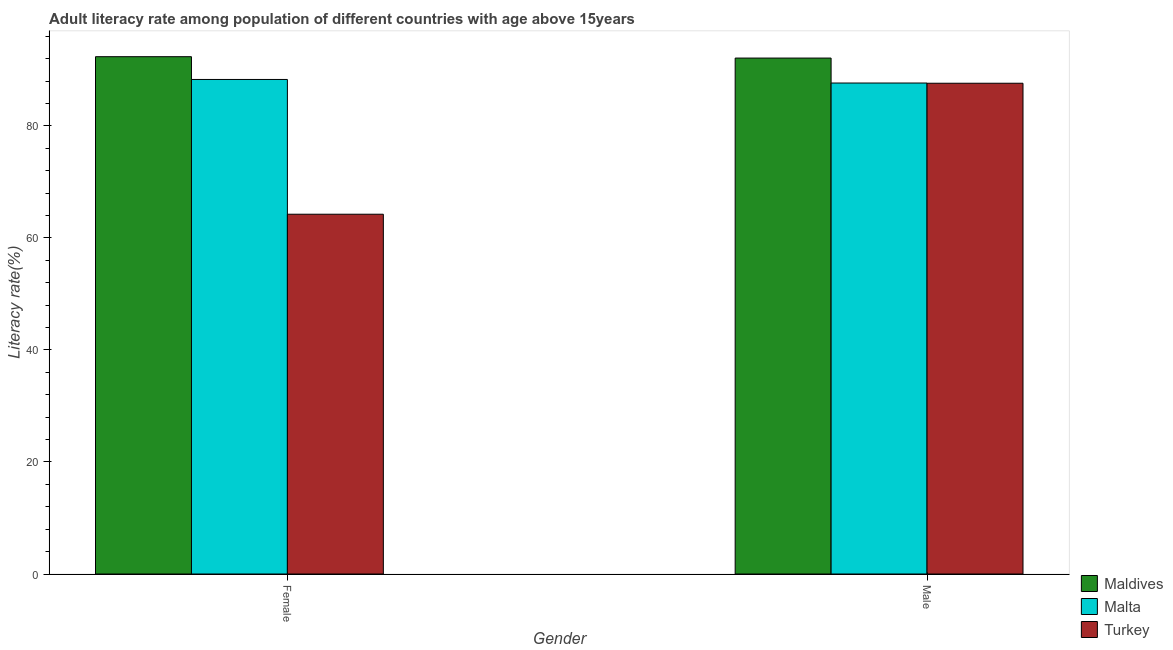How many different coloured bars are there?
Make the answer very short. 3. Are the number of bars per tick equal to the number of legend labels?
Your answer should be compact. Yes. What is the label of the 2nd group of bars from the left?
Your answer should be compact. Male. What is the female adult literacy rate in Maldives?
Keep it short and to the point. 92.36. Across all countries, what is the maximum female adult literacy rate?
Ensure brevity in your answer.  92.36. Across all countries, what is the minimum male adult literacy rate?
Your response must be concise. 87.62. In which country was the female adult literacy rate maximum?
Provide a short and direct response. Maldives. In which country was the male adult literacy rate minimum?
Offer a terse response. Turkey. What is the total male adult literacy rate in the graph?
Provide a short and direct response. 267.39. What is the difference between the male adult literacy rate in Turkey and that in Malta?
Make the answer very short. -0.04. What is the difference between the male adult literacy rate in Malta and the female adult literacy rate in Turkey?
Ensure brevity in your answer.  23.43. What is the average male adult literacy rate per country?
Ensure brevity in your answer.  89.13. What is the difference between the male adult literacy rate and female adult literacy rate in Turkey?
Provide a short and direct response. 23.39. In how many countries, is the male adult literacy rate greater than 72 %?
Your answer should be compact. 3. What is the ratio of the male adult literacy rate in Turkey to that in Maldives?
Your response must be concise. 0.95. In how many countries, is the male adult literacy rate greater than the average male adult literacy rate taken over all countries?
Ensure brevity in your answer.  1. What does the 1st bar from the right in Male represents?
Keep it short and to the point. Turkey. How many countries are there in the graph?
Your answer should be compact. 3. Are the values on the major ticks of Y-axis written in scientific E-notation?
Your response must be concise. No. Does the graph contain grids?
Your response must be concise. No. Where does the legend appear in the graph?
Give a very brief answer. Bottom right. What is the title of the graph?
Make the answer very short. Adult literacy rate among population of different countries with age above 15years. What is the label or title of the X-axis?
Give a very brief answer. Gender. What is the label or title of the Y-axis?
Your answer should be very brief. Literacy rate(%). What is the Literacy rate(%) in Maldives in Female?
Offer a very short reply. 92.36. What is the Literacy rate(%) of Malta in Female?
Your answer should be compact. 88.29. What is the Literacy rate(%) in Turkey in Female?
Offer a very short reply. 64.23. What is the Literacy rate(%) in Maldives in Male?
Your answer should be compact. 92.11. What is the Literacy rate(%) of Malta in Male?
Your answer should be very brief. 87.66. What is the Literacy rate(%) of Turkey in Male?
Keep it short and to the point. 87.62. Across all Gender, what is the maximum Literacy rate(%) in Maldives?
Your answer should be very brief. 92.36. Across all Gender, what is the maximum Literacy rate(%) in Malta?
Your response must be concise. 88.29. Across all Gender, what is the maximum Literacy rate(%) in Turkey?
Your answer should be compact. 87.62. Across all Gender, what is the minimum Literacy rate(%) in Maldives?
Make the answer very short. 92.11. Across all Gender, what is the minimum Literacy rate(%) of Malta?
Offer a terse response. 87.66. Across all Gender, what is the minimum Literacy rate(%) in Turkey?
Make the answer very short. 64.23. What is the total Literacy rate(%) of Maldives in the graph?
Provide a succinct answer. 184.47. What is the total Literacy rate(%) in Malta in the graph?
Give a very brief answer. 175.95. What is the total Literacy rate(%) in Turkey in the graph?
Give a very brief answer. 151.85. What is the difference between the Literacy rate(%) of Maldives in Female and that in Male?
Offer a terse response. 0.24. What is the difference between the Literacy rate(%) in Malta in Female and that in Male?
Provide a succinct answer. 0.64. What is the difference between the Literacy rate(%) of Turkey in Female and that in Male?
Ensure brevity in your answer.  -23.39. What is the difference between the Literacy rate(%) in Maldives in Female and the Literacy rate(%) in Malta in Male?
Make the answer very short. 4.7. What is the difference between the Literacy rate(%) in Maldives in Female and the Literacy rate(%) in Turkey in Male?
Your answer should be compact. 4.74. What is the difference between the Literacy rate(%) in Malta in Female and the Literacy rate(%) in Turkey in Male?
Offer a very short reply. 0.67. What is the average Literacy rate(%) in Maldives per Gender?
Make the answer very short. 92.24. What is the average Literacy rate(%) in Malta per Gender?
Give a very brief answer. 87.97. What is the average Literacy rate(%) in Turkey per Gender?
Ensure brevity in your answer.  75.93. What is the difference between the Literacy rate(%) in Maldives and Literacy rate(%) in Malta in Female?
Keep it short and to the point. 4.07. What is the difference between the Literacy rate(%) in Maldives and Literacy rate(%) in Turkey in Female?
Provide a succinct answer. 28.13. What is the difference between the Literacy rate(%) in Malta and Literacy rate(%) in Turkey in Female?
Keep it short and to the point. 24.06. What is the difference between the Literacy rate(%) in Maldives and Literacy rate(%) in Malta in Male?
Provide a succinct answer. 4.46. What is the difference between the Literacy rate(%) of Maldives and Literacy rate(%) of Turkey in Male?
Provide a succinct answer. 4.49. What is the difference between the Literacy rate(%) in Malta and Literacy rate(%) in Turkey in Male?
Make the answer very short. 0.04. What is the ratio of the Literacy rate(%) of Maldives in Female to that in Male?
Provide a short and direct response. 1. What is the ratio of the Literacy rate(%) of Malta in Female to that in Male?
Keep it short and to the point. 1.01. What is the ratio of the Literacy rate(%) of Turkey in Female to that in Male?
Offer a very short reply. 0.73. What is the difference between the highest and the second highest Literacy rate(%) of Maldives?
Your response must be concise. 0.24. What is the difference between the highest and the second highest Literacy rate(%) in Malta?
Your answer should be compact. 0.64. What is the difference between the highest and the second highest Literacy rate(%) in Turkey?
Your answer should be compact. 23.39. What is the difference between the highest and the lowest Literacy rate(%) of Maldives?
Offer a terse response. 0.24. What is the difference between the highest and the lowest Literacy rate(%) of Malta?
Keep it short and to the point. 0.64. What is the difference between the highest and the lowest Literacy rate(%) in Turkey?
Provide a succinct answer. 23.39. 